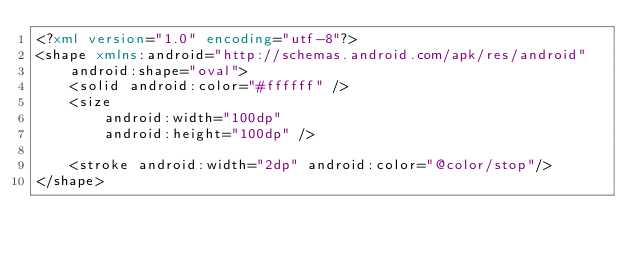<code> <loc_0><loc_0><loc_500><loc_500><_XML_><?xml version="1.0" encoding="utf-8"?>
<shape xmlns:android="http://schemas.android.com/apk/res/android"
    android:shape="oval">
    <solid android:color="#ffffff" />
    <size
        android:width="100dp"
        android:height="100dp" />

    <stroke android:width="2dp" android:color="@color/stop"/>
</shape>
</code> 